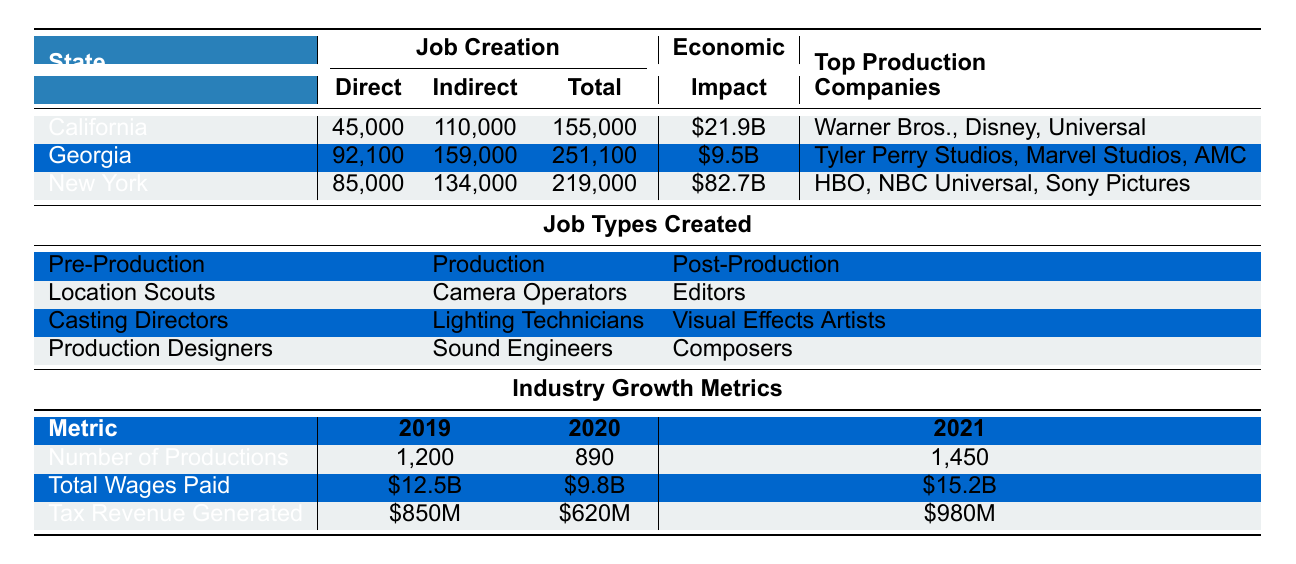What is the total number of jobs created in Georgia due to the tax incentive program? The total jobs created in Georgia as indicated in the table is listed under "Job Creation" for Georgia. It states a total of 251,100 jobs were created.
Answer: 251,100 Which state has the highest economic impact due to tax incentives? The economic impact for each state is detailed in the table. California shows an economic impact of $21.9 billion, Georgia shows $9.5 billion, and New York shows $82.7 billion. Thus, New York has the highest economic impact.
Answer: New York How many direct jobs were created in California? The number of direct jobs created in California is specified under the "Job Creation" section in the table, listing 45,000 direct jobs created.
Answer: 45,000 What is the difference between the total jobs created in New York and Georgia? To find the difference, subtract the total jobs in Georgia (251,100) from those in New York (219,000). The calculation is 251,100 - 219,000 = 32,100.
Answer: 32,100 True or False: Tyler Perry Studios is listed as a top production company in California. The table specifies the top production companies for each state. Tyler Perry Studios is listed under Georgia, not California, making the statement false.
Answer: False What is the average economic impact of the three states combined? First, add the economic impacts together: $21.9 billion (California) + $9.5 billion (Georgia) + $82.7 billion (New York) = $114.1 billion. Then, divide by 3 to find the average: $114.1 billion / 3 ≈ $38.03 billion.
Answer: $38.03 billion Which job category contributes the most jobs in pre-production? The job types created in the pre-production category include Location Scouts, Casting Directors, and Production Designers. Since no values are provided for the number of jobs, we cannot determine which contributes the most, but the presence of three job roles indicates a balanced contribution.
Answer: Not determinable How many indirect jobs were created in New York? The indirect jobs created in New York are listed in the table under "Job Creation," showing a total of 134,000 indirect jobs.
Answer: 134,000 Which state saw an increase in the number of productions from 2020 to 2021? Comparing the number of productions listed for 2020 (890) and 2021 (1,450), there is an increase of 560 productions in 2021. Thus, the state that saw this increase is not specified per state but shows an overall increase.
Answer: Overall increase in productions What was the total wages paid in the film industry for 2020? The table indicates that the total wages paid in 2020 were $9.8 billion as specified under "Total Wages Paid."
Answer: $9.8 billion Which has more job creation: Total jobs in California or total jobs in New York? California has 155,000 total jobs created, and New York has 219,000 total jobs created. Comparing these two, New York has more job creation than California.
Answer: New York has more job creation 